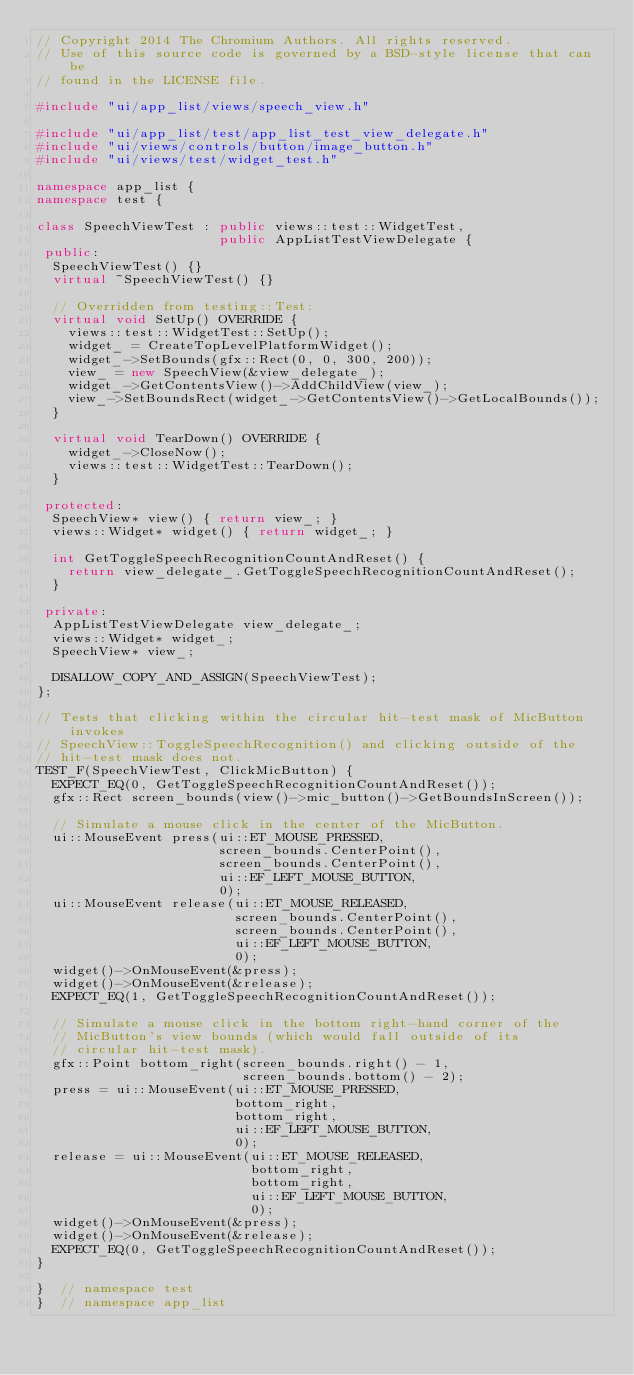<code> <loc_0><loc_0><loc_500><loc_500><_C++_>// Copyright 2014 The Chromium Authors. All rights reserved.
// Use of this source code is governed by a BSD-style license that can be
// found in the LICENSE file.

#include "ui/app_list/views/speech_view.h"

#include "ui/app_list/test/app_list_test_view_delegate.h"
#include "ui/views/controls/button/image_button.h"
#include "ui/views/test/widget_test.h"

namespace app_list {
namespace test {

class SpeechViewTest : public views::test::WidgetTest,
                       public AppListTestViewDelegate {
 public:
  SpeechViewTest() {}
  virtual ~SpeechViewTest() {}

  // Overridden from testing::Test:
  virtual void SetUp() OVERRIDE {
    views::test::WidgetTest::SetUp();
    widget_ = CreateTopLevelPlatformWidget();
    widget_->SetBounds(gfx::Rect(0, 0, 300, 200));
    view_ = new SpeechView(&view_delegate_);
    widget_->GetContentsView()->AddChildView(view_);
    view_->SetBoundsRect(widget_->GetContentsView()->GetLocalBounds());
  }

  virtual void TearDown() OVERRIDE {
    widget_->CloseNow();
    views::test::WidgetTest::TearDown();
  }

 protected:
  SpeechView* view() { return view_; }
  views::Widget* widget() { return widget_; }

  int GetToggleSpeechRecognitionCountAndReset() {
    return view_delegate_.GetToggleSpeechRecognitionCountAndReset();
  }

 private:
  AppListTestViewDelegate view_delegate_;
  views::Widget* widget_;
  SpeechView* view_;

  DISALLOW_COPY_AND_ASSIGN(SpeechViewTest);
};

// Tests that clicking within the circular hit-test mask of MicButton invokes
// SpeechView::ToggleSpeechRecognition() and clicking outside of the
// hit-test mask does not.
TEST_F(SpeechViewTest, ClickMicButton) {
  EXPECT_EQ(0, GetToggleSpeechRecognitionCountAndReset());
  gfx::Rect screen_bounds(view()->mic_button()->GetBoundsInScreen());

  // Simulate a mouse click in the center of the MicButton.
  ui::MouseEvent press(ui::ET_MOUSE_PRESSED,
                       screen_bounds.CenterPoint(),
                       screen_bounds.CenterPoint(),
                       ui::EF_LEFT_MOUSE_BUTTON,
                       0);
  ui::MouseEvent release(ui::ET_MOUSE_RELEASED,
                         screen_bounds.CenterPoint(),
                         screen_bounds.CenterPoint(),
                         ui::EF_LEFT_MOUSE_BUTTON,
                         0);
  widget()->OnMouseEvent(&press);
  widget()->OnMouseEvent(&release);
  EXPECT_EQ(1, GetToggleSpeechRecognitionCountAndReset());

  // Simulate a mouse click in the bottom right-hand corner of the
  // MicButton's view bounds (which would fall outside of its
  // circular hit-test mask).
  gfx::Point bottom_right(screen_bounds.right() - 1,
                          screen_bounds.bottom() - 2);
  press = ui::MouseEvent(ui::ET_MOUSE_PRESSED,
                         bottom_right,
                         bottom_right,
                         ui::EF_LEFT_MOUSE_BUTTON,
                         0);
  release = ui::MouseEvent(ui::ET_MOUSE_RELEASED,
                           bottom_right,
                           bottom_right,
                           ui::EF_LEFT_MOUSE_BUTTON,
                           0);
  widget()->OnMouseEvent(&press);
  widget()->OnMouseEvent(&release);
  EXPECT_EQ(0, GetToggleSpeechRecognitionCountAndReset());
}

}  // namespace test
}  // namespace app_list
</code> 